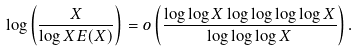<formula> <loc_0><loc_0><loc_500><loc_500>\log \left ( \frac { X } { \log X E ( X ) } \right ) = o \left ( \frac { \log \log X \log \log \log \log X } { \log \log \log X } \right ) .</formula> 